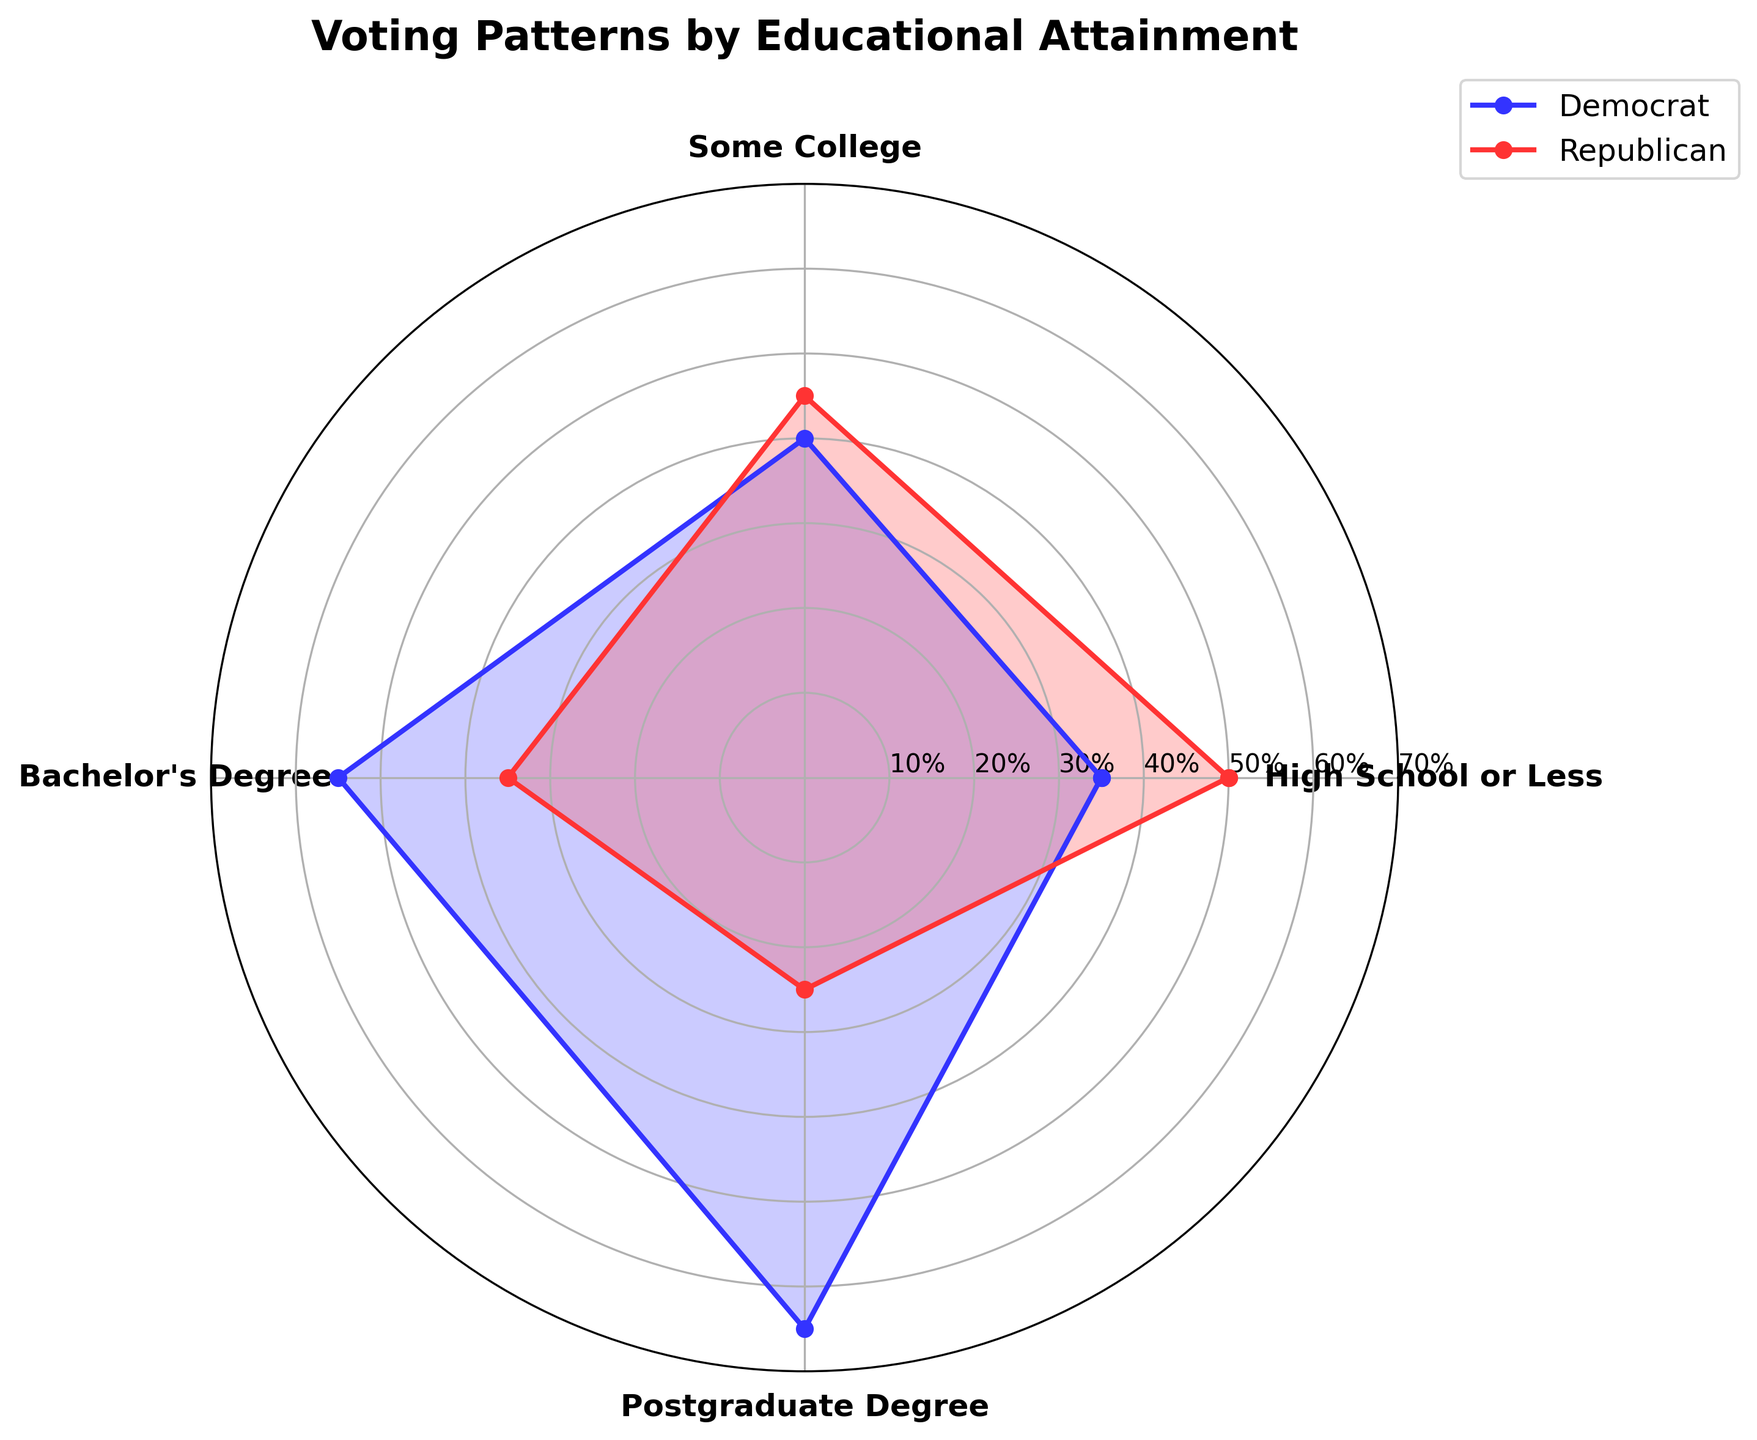What is the title of the figure? The title of the figure is located at the top and provides a summary of what the chart represents. It helps viewers quickly understand the context of the data being presented.
Answer: Voting Patterns by Educational Attainment What is the highest percentage of Democrats among the educational levels? To find the highest percentage of Democrat votes, observe the peaks of the blue area in the chart. The highest peak corresponds to the Postgraduate Degree category.
Answer: 65% Which educational group has the most Republican supporters? To determine this, look at the red areas on the chart and identify the tallest red segment, which represents the highest Republican support. It occurs at the High School or Less category.
Answer: High School or Less How does the percentage of Democrats differ between those with a Bachelor's Degree and those with a Postgraduate Degree? The percentage of Democrats for a Bachelor's Degree is 55%, while for a Postgraduate Degree, it is 65%. Calculate the difference: 65% - 55% = 10%.
Answer: 10% Compare the Republican support between High School or Less and Some College categories. Observe the red areas for both categories. High School or Less has 50% Republican support, while Some College has 45%. Calculate the difference: 50% - 45% = 5%.
Answer: 5% In which educational group do Democrats have exactly twice the percentage of Independents? To answer this, find Democratic percentage values and compare them to double the Independent percentages. The Democrat percentage must be double the Independents percentage. For Postgraduate Degree, Democrat is 65% and Independent is 10%, and 65% is twice 10%.
Answer: Postgraduate Degree What is the combined percentage of Democrats and Republicans for those with Some College? For those with Some College, the percentage of Democrats is 40% and Republicans is 45%. Add these two percentages together: 40% + 45% = 85%.
Answer: 85% Does any educational group have equal representation between Democrats and Republicans? Examine the chart to find if any slices for Democrats (blue) and Republicans (red) are of equal height. None of the educational levels show equal representation.
Answer: No Which educational group has the smallest percentage of Independent voters? Identify the smallest yellow segment in the chart. The Postgraduate Degree category has the smallest percentage of Independents at 10%.
Answer: Postgraduate Degree 